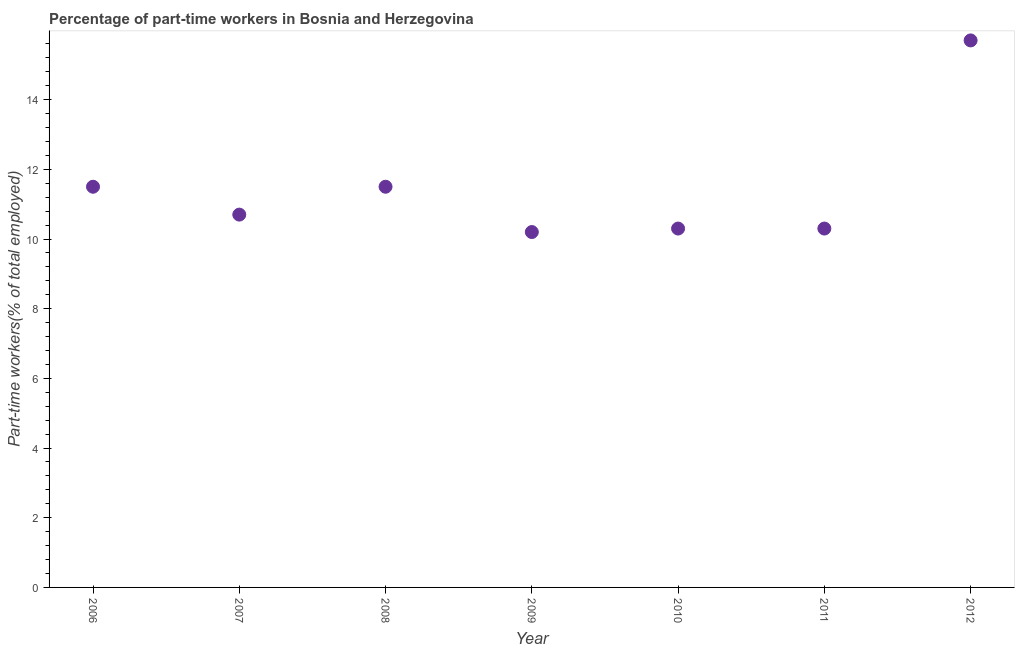What is the percentage of part-time workers in 2010?
Ensure brevity in your answer.  10.3. Across all years, what is the maximum percentage of part-time workers?
Keep it short and to the point. 15.7. Across all years, what is the minimum percentage of part-time workers?
Keep it short and to the point. 10.2. In which year was the percentage of part-time workers maximum?
Make the answer very short. 2012. What is the sum of the percentage of part-time workers?
Provide a short and direct response. 80.2. What is the average percentage of part-time workers per year?
Offer a very short reply. 11.46. What is the median percentage of part-time workers?
Your response must be concise. 10.7. Is the percentage of part-time workers in 2007 less than that in 2008?
Offer a very short reply. Yes. What is the difference between the highest and the second highest percentage of part-time workers?
Offer a very short reply. 4.2. Is the sum of the percentage of part-time workers in 2009 and 2011 greater than the maximum percentage of part-time workers across all years?
Offer a very short reply. Yes. How many dotlines are there?
Ensure brevity in your answer.  1. Does the graph contain grids?
Your answer should be compact. No. What is the title of the graph?
Provide a succinct answer. Percentage of part-time workers in Bosnia and Herzegovina. What is the label or title of the X-axis?
Keep it short and to the point. Year. What is the label or title of the Y-axis?
Provide a succinct answer. Part-time workers(% of total employed). What is the Part-time workers(% of total employed) in 2007?
Provide a succinct answer. 10.7. What is the Part-time workers(% of total employed) in 2009?
Ensure brevity in your answer.  10.2. What is the Part-time workers(% of total employed) in 2010?
Provide a short and direct response. 10.3. What is the Part-time workers(% of total employed) in 2011?
Your answer should be compact. 10.3. What is the Part-time workers(% of total employed) in 2012?
Your answer should be very brief. 15.7. What is the difference between the Part-time workers(% of total employed) in 2006 and 2012?
Give a very brief answer. -4.2. What is the difference between the Part-time workers(% of total employed) in 2007 and 2009?
Your answer should be compact. 0.5. What is the difference between the Part-time workers(% of total employed) in 2007 and 2012?
Your response must be concise. -5. What is the difference between the Part-time workers(% of total employed) in 2008 and 2009?
Your answer should be very brief. 1.3. What is the difference between the Part-time workers(% of total employed) in 2009 and 2012?
Provide a succinct answer. -5.5. What is the difference between the Part-time workers(% of total employed) in 2010 and 2011?
Your response must be concise. 0. What is the ratio of the Part-time workers(% of total employed) in 2006 to that in 2007?
Provide a short and direct response. 1.07. What is the ratio of the Part-time workers(% of total employed) in 2006 to that in 2008?
Your answer should be compact. 1. What is the ratio of the Part-time workers(% of total employed) in 2006 to that in 2009?
Your answer should be very brief. 1.13. What is the ratio of the Part-time workers(% of total employed) in 2006 to that in 2010?
Provide a short and direct response. 1.12. What is the ratio of the Part-time workers(% of total employed) in 2006 to that in 2011?
Give a very brief answer. 1.12. What is the ratio of the Part-time workers(% of total employed) in 2006 to that in 2012?
Your answer should be very brief. 0.73. What is the ratio of the Part-time workers(% of total employed) in 2007 to that in 2008?
Your answer should be very brief. 0.93. What is the ratio of the Part-time workers(% of total employed) in 2007 to that in 2009?
Your response must be concise. 1.05. What is the ratio of the Part-time workers(% of total employed) in 2007 to that in 2010?
Offer a terse response. 1.04. What is the ratio of the Part-time workers(% of total employed) in 2007 to that in 2011?
Provide a succinct answer. 1.04. What is the ratio of the Part-time workers(% of total employed) in 2007 to that in 2012?
Give a very brief answer. 0.68. What is the ratio of the Part-time workers(% of total employed) in 2008 to that in 2009?
Your response must be concise. 1.13. What is the ratio of the Part-time workers(% of total employed) in 2008 to that in 2010?
Offer a very short reply. 1.12. What is the ratio of the Part-time workers(% of total employed) in 2008 to that in 2011?
Your response must be concise. 1.12. What is the ratio of the Part-time workers(% of total employed) in 2008 to that in 2012?
Provide a short and direct response. 0.73. What is the ratio of the Part-time workers(% of total employed) in 2009 to that in 2012?
Keep it short and to the point. 0.65. What is the ratio of the Part-time workers(% of total employed) in 2010 to that in 2012?
Provide a succinct answer. 0.66. What is the ratio of the Part-time workers(% of total employed) in 2011 to that in 2012?
Ensure brevity in your answer.  0.66. 